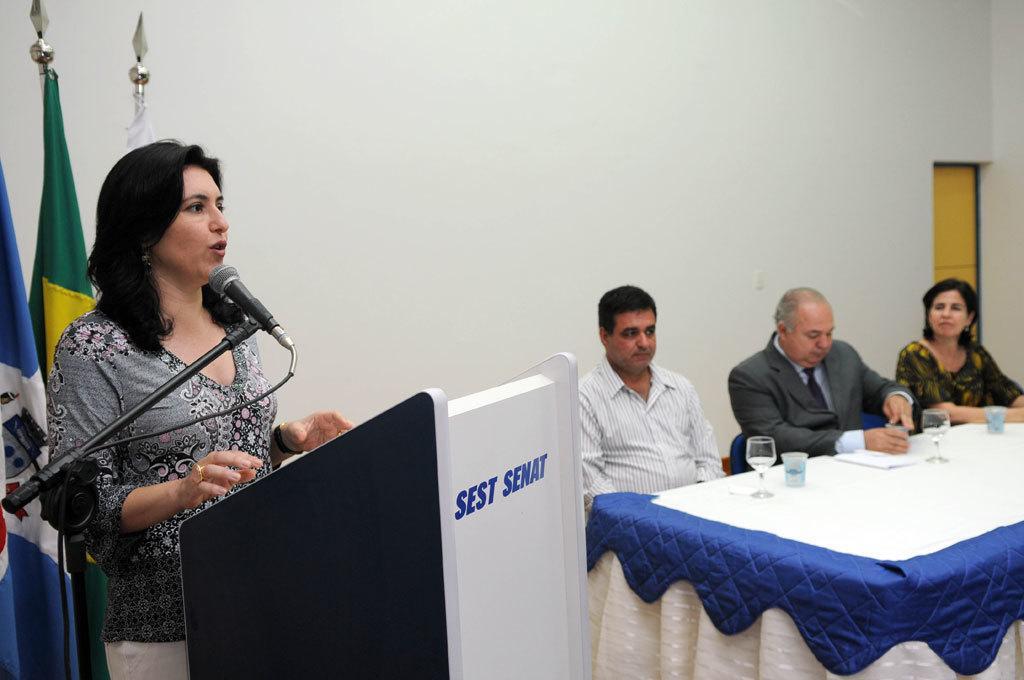In one or two sentences, can you explain what this image depicts? a person is standing at the left and speaking into microphone. behind her there are 3 flags a wooden box is present in front of her. to her right there is a table on which there are papers and glasses. people are seated on the chair. the person at the center is wearing a suit. behind them there is a white wall. 